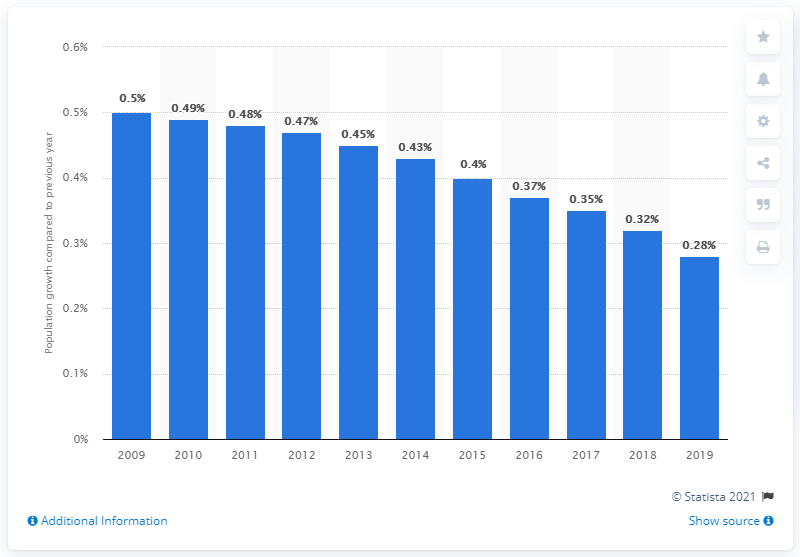Indicate a few pertinent items in this graphic. The population of Thailand increased by 0.28% in 2019. 